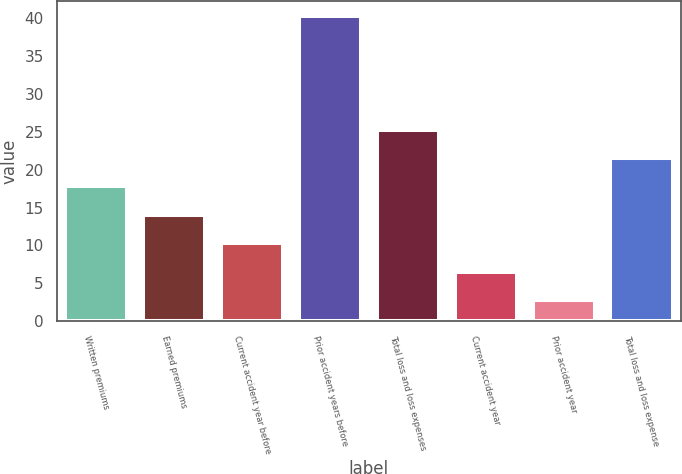Convert chart. <chart><loc_0><loc_0><loc_500><loc_500><bar_chart><fcel>Written premiums<fcel>Earned premiums<fcel>Current accident year before<fcel>Prior accident years before<fcel>Total loss and loss expenses<fcel>Current accident year<fcel>Prior accident year<fcel>Total loss and loss expense<nl><fcel>17.78<fcel>14.02<fcel>10.26<fcel>40.3<fcel>25.3<fcel>6.5<fcel>2.74<fcel>21.54<nl></chart> 